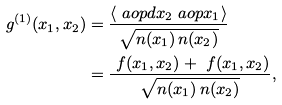Convert formula to latex. <formula><loc_0><loc_0><loc_500><loc_500>g ^ { ( 1 ) } ( x _ { 1 } , x _ { 2 } ) & = \frac { \langle \ a o p d { x _ { 2 } } \ a o p { x _ { 1 } } \rangle } { \sqrt { n ( x _ { 1 } ) \, n ( x _ { 2 } ) } } \\ & = \frac { \ f ( x _ { 1 } , x _ { 2 } ) + \ f ( x _ { 1 } , x _ { 2 } ) } { \sqrt { n ( x _ { 1 } ) \, n ( x _ { 2 } ) } } ,</formula> 